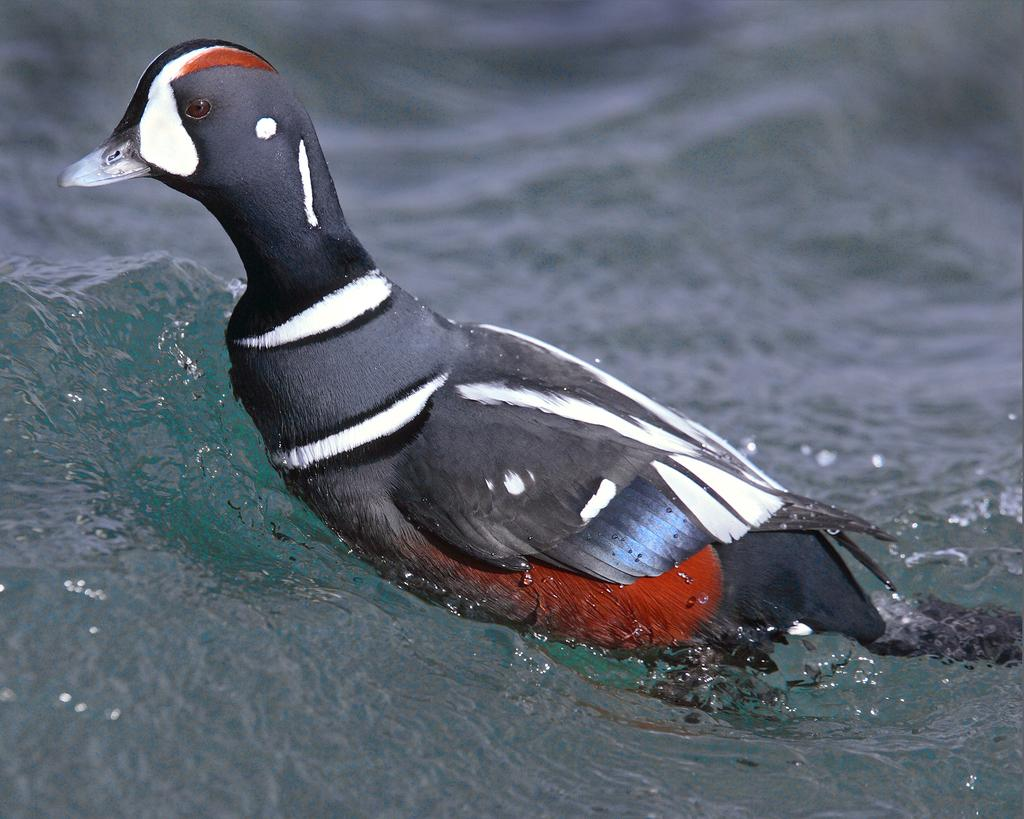What type of animal can be seen in the water in the image? There is a bird in the water in the image. Can you describe the bird's location in the image? The bird is in the water in the image. What group of people discovered the bird's new habitat in the image? There is no group of people or discovery mentioned in the image; it simply shows a bird in the water. 